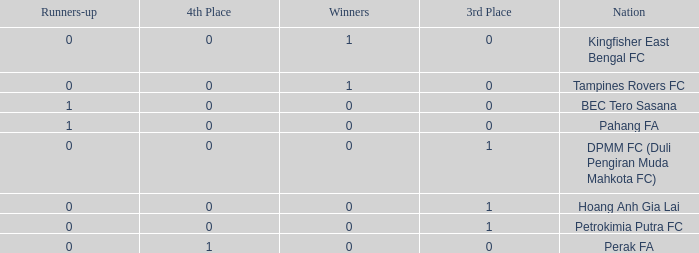Name the highest 3rd place for nation of perak fa 0.0. Can you parse all the data within this table? {'header': ['Runners-up', '4th Place', 'Winners', '3rd Place', 'Nation'], 'rows': [['0', '0', '1', '0', 'Kingfisher East Bengal FC'], ['0', '0', '1', '0', 'Tampines Rovers FC'], ['1', '0', '0', '0', 'BEC Tero Sasana'], ['1', '0', '0', '0', 'Pahang FA'], ['0', '0', '0', '1', 'DPMM FC (Duli Pengiran Muda Mahkota FC)'], ['0', '0', '0', '1', 'Hoang Anh Gia Lai'], ['0', '0', '0', '1', 'Petrokimia Putra FC'], ['0', '1', '0', '0', 'Perak FA']]} 